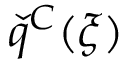Convert formula to latex. <formula><loc_0><loc_0><loc_500><loc_500>\check { q } ^ { C } ( \xi )</formula> 